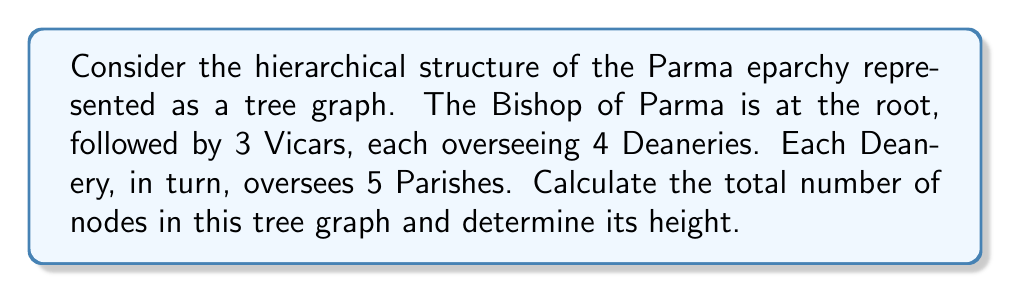Provide a solution to this math problem. Let's analyze this hierarchical structure step by step:

1. Root node:
   - The Bishop of Parma represents the root node.
   
2. First level (Vicars):
   - There are 3 Vicars directly under the Bishop.
   
3. Second level (Deaneries):
   - Each Vicar oversees 4 Deaneries.
   - Total number of Deaneries = $3 \times 4 = 12$
   
4. Third level (Parishes):
   - Each Deanery oversees 5 Parishes.
   - Total number of Parishes = $12 \times 5 = 60$

5. Calculating total nodes:
   - Root (Bishop): 1
   - Vicars: 3
   - Deaneries: 12
   - Parishes: 60
   - Total nodes = $1 + 3 + 12 + 60 = 76$

6. Determining tree height:
   - The height of a tree is the number of edges on the longest path from the root to a leaf.
   - In this case, the path goes from Bishop → Vicar → Deanery → Parish
   - This path contains 3 edges, so the height of the tree is 3.

The tree can be represented as follows:

[asy]
unitsize(1cm);

// Draw nodes
dot((0,0));  // Bishop
for (int i=0; i<3; ++i) {
  dot((-3+3*i,-2));  // Vicars
  for (int j=0; j<4; ++j) {
    dot((-4+3*i+j,-4));  // Deaneries
  }
}

// Draw edges
draw((0,0)--(-3,-2));
draw((0,0)--(0,-2));
draw((0,0)--(3,-2));
for (int i=0; i<3; ++i) {
  for (int j=0; j<4; ++j) {
    draw((-3+3*i,-2)--(-4+3*i+j,-4));
  }
}

// Labels
label("Bishop", (0,0.5));
label("Vicars", (0,-2.5));
label("Deaneries", (0,-4.5));
label("Parishes (not shown)", (0,-5.5));
[/asy]

Note: The parishes are not shown in the diagram to maintain clarity, but they would be the leaf nodes at the fourth level of the tree.
Answer: Total number of nodes: 76
Height of the tree: 3 